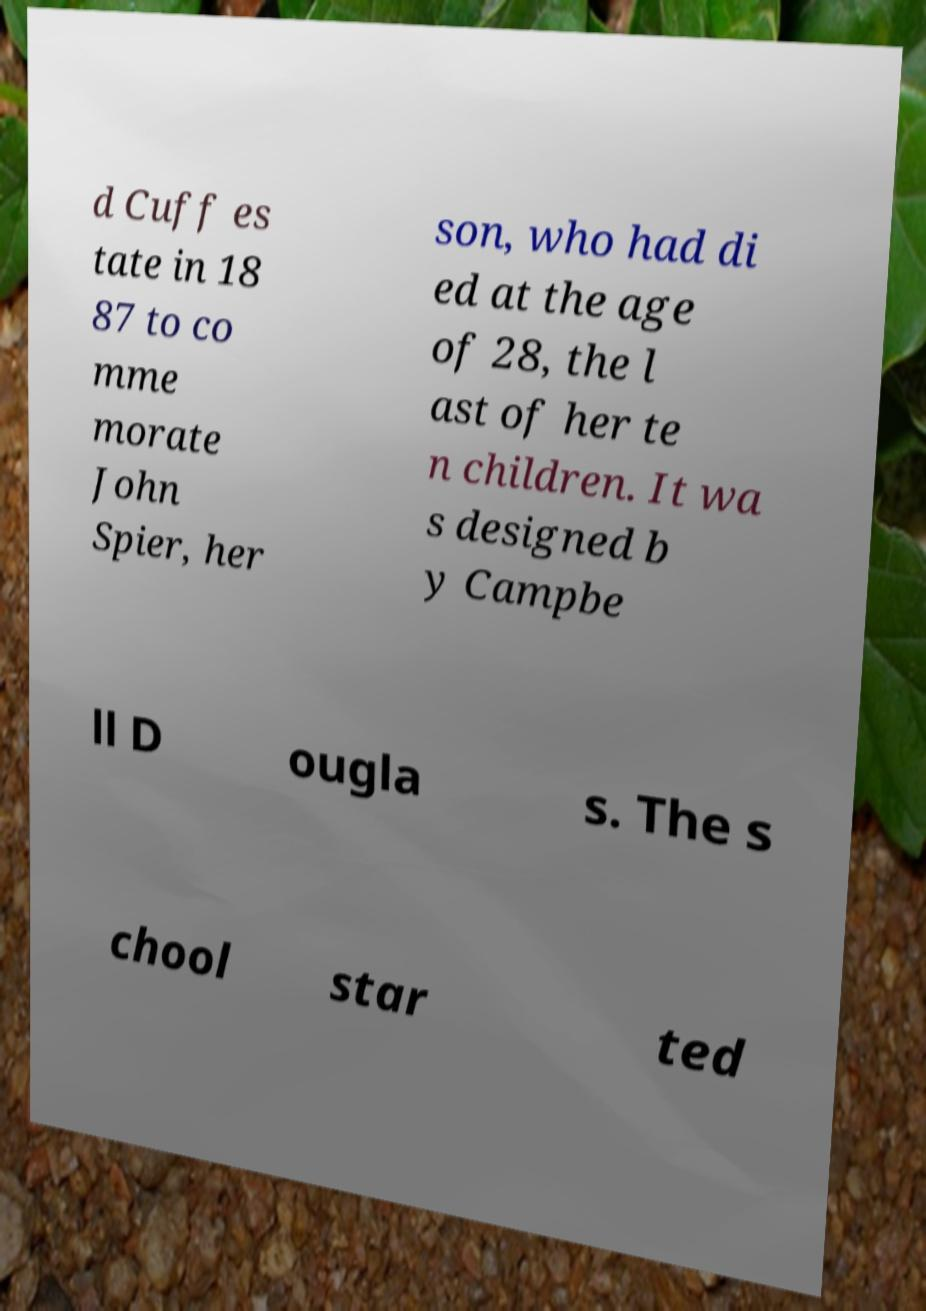What messages or text are displayed in this image? I need them in a readable, typed format. d Cuff es tate in 18 87 to co mme morate John Spier, her son, who had di ed at the age of 28, the l ast of her te n children. It wa s designed b y Campbe ll D ougla s. The s chool star ted 